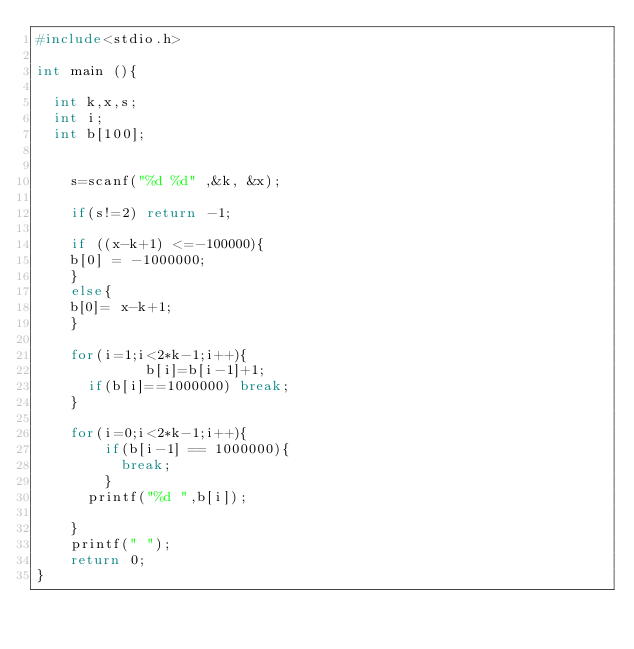Convert code to text. <code><loc_0><loc_0><loc_500><loc_500><_C_>#include<stdio.h>

int main (){

  int k,x,s;
  int i;
  int b[100];
 
  
	s=scanf("%d %d" ,&k, &x);
  
  	if(s!=2) return -1;
  
	if ((x-k+1) <=-100000){
    b[0] = -1000000;
    }  
	else{
    b[0]= x-k+1;
    }  

  	for(i=1;i<2*k-1;i++){
    	     b[i]=b[i-1]+1;
      if(b[i]==1000000) break;
    }
  
	for(i=0;i<2*k-1;i++){
    	if(b[i-1] == 1000000){ 
          break;
        }
      printf("%d ",b[i]);
    
    }
  	printf(" ");
	return 0;
}</code> 